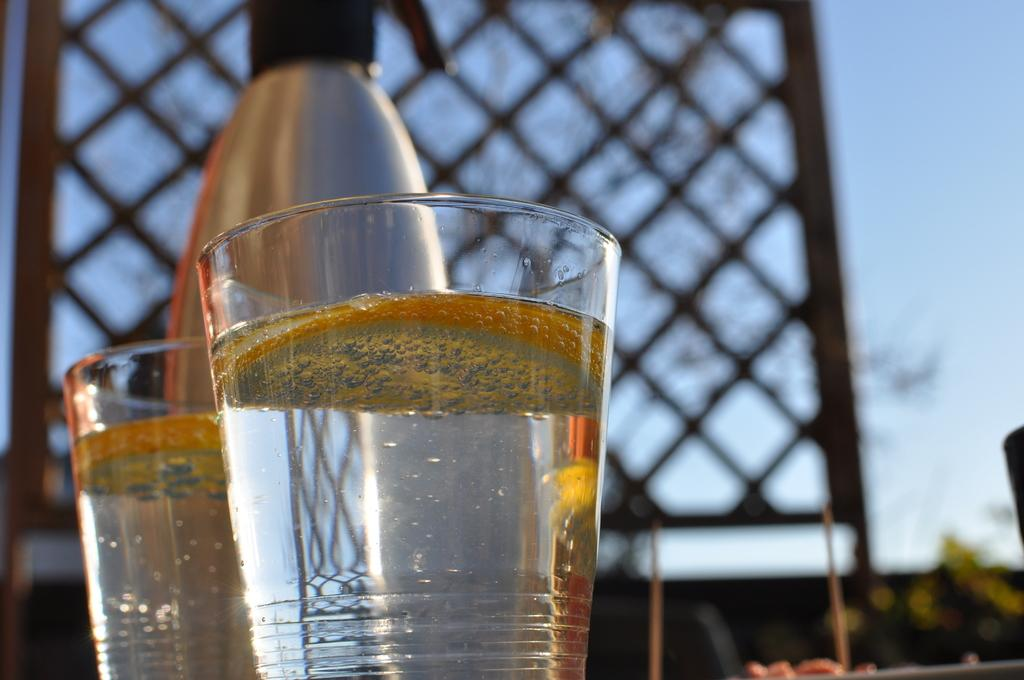What is in the bottle that is visible in the image? There is a bottled in the image, but the contents are not specified. What are the glasses containing in the image? The glasses contain water in the image. What is visible in the background of the image? The sky is visible in the image. Where is the scarecrow located in the image? There is no scarecrow present in the image. What type of toy can be seen playing with the rabbits in the image? There are no toys or rabbits present in the image. 